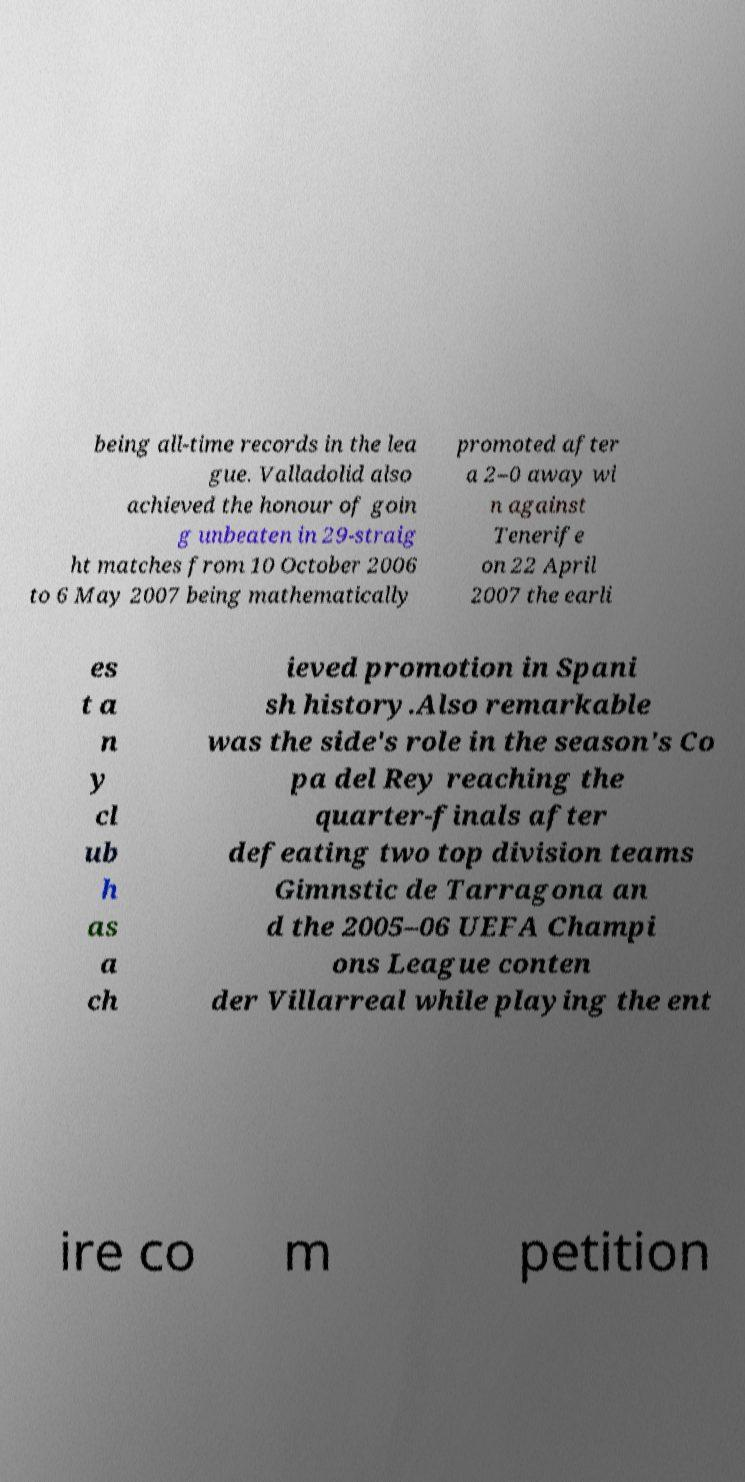Could you extract and type out the text from this image? being all-time records in the lea gue. Valladolid also achieved the honour of goin g unbeaten in 29-straig ht matches from 10 October 2006 to 6 May 2007 being mathematically promoted after a 2–0 away wi n against Tenerife on 22 April 2007 the earli es t a n y cl ub h as a ch ieved promotion in Spani sh history.Also remarkable was the side's role in the season's Co pa del Rey reaching the quarter-finals after defeating two top division teams Gimnstic de Tarragona an d the 2005–06 UEFA Champi ons League conten der Villarreal while playing the ent ire co m petition 